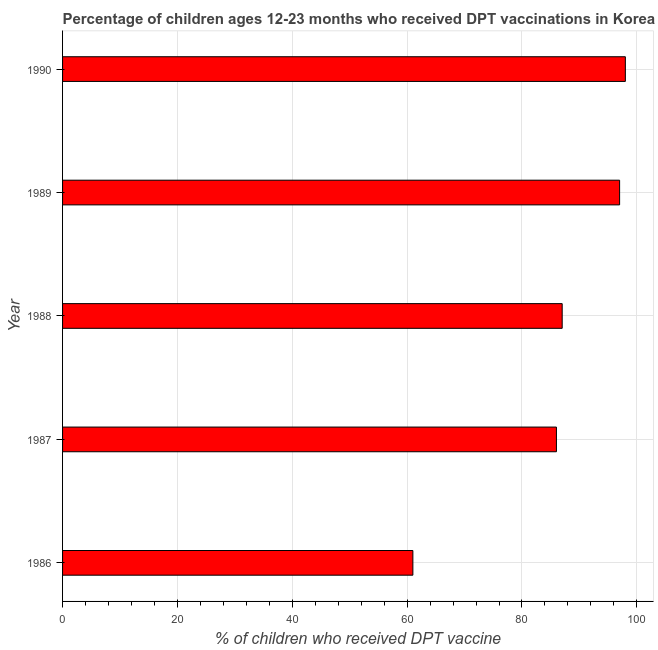Does the graph contain any zero values?
Your answer should be compact. No. What is the title of the graph?
Give a very brief answer. Percentage of children ages 12-23 months who received DPT vaccinations in Korea (Democratic). What is the label or title of the X-axis?
Provide a succinct answer. % of children who received DPT vaccine. What is the label or title of the Y-axis?
Make the answer very short. Year. Across all years, what is the maximum percentage of children who received dpt vaccine?
Offer a terse response. 98. In which year was the percentage of children who received dpt vaccine minimum?
Make the answer very short. 1986. What is the sum of the percentage of children who received dpt vaccine?
Give a very brief answer. 429. What is the average percentage of children who received dpt vaccine per year?
Your answer should be very brief. 85. What is the median percentage of children who received dpt vaccine?
Your answer should be compact. 87. In how many years, is the percentage of children who received dpt vaccine greater than 16 %?
Keep it short and to the point. 5. What is the ratio of the percentage of children who received dpt vaccine in 1986 to that in 1987?
Your answer should be very brief. 0.71. What is the difference between the highest and the second highest percentage of children who received dpt vaccine?
Give a very brief answer. 1. In how many years, is the percentage of children who received dpt vaccine greater than the average percentage of children who received dpt vaccine taken over all years?
Ensure brevity in your answer.  4. How many bars are there?
Your response must be concise. 5. Are all the bars in the graph horizontal?
Provide a succinct answer. Yes. What is the % of children who received DPT vaccine in 1986?
Make the answer very short. 61. What is the % of children who received DPT vaccine in 1987?
Keep it short and to the point. 86. What is the % of children who received DPT vaccine in 1989?
Your response must be concise. 97. What is the difference between the % of children who received DPT vaccine in 1986 and 1988?
Offer a terse response. -26. What is the difference between the % of children who received DPT vaccine in 1986 and 1989?
Provide a succinct answer. -36. What is the difference between the % of children who received DPT vaccine in 1986 and 1990?
Make the answer very short. -37. What is the difference between the % of children who received DPT vaccine in 1987 and 1988?
Your answer should be very brief. -1. What is the difference between the % of children who received DPT vaccine in 1987 and 1990?
Your answer should be very brief. -12. What is the difference between the % of children who received DPT vaccine in 1988 and 1989?
Your response must be concise. -10. What is the difference between the % of children who received DPT vaccine in 1988 and 1990?
Provide a short and direct response. -11. What is the ratio of the % of children who received DPT vaccine in 1986 to that in 1987?
Your answer should be very brief. 0.71. What is the ratio of the % of children who received DPT vaccine in 1986 to that in 1988?
Make the answer very short. 0.7. What is the ratio of the % of children who received DPT vaccine in 1986 to that in 1989?
Your answer should be compact. 0.63. What is the ratio of the % of children who received DPT vaccine in 1986 to that in 1990?
Your answer should be compact. 0.62. What is the ratio of the % of children who received DPT vaccine in 1987 to that in 1989?
Your answer should be very brief. 0.89. What is the ratio of the % of children who received DPT vaccine in 1987 to that in 1990?
Ensure brevity in your answer.  0.88. What is the ratio of the % of children who received DPT vaccine in 1988 to that in 1989?
Ensure brevity in your answer.  0.9. What is the ratio of the % of children who received DPT vaccine in 1988 to that in 1990?
Provide a short and direct response. 0.89. 